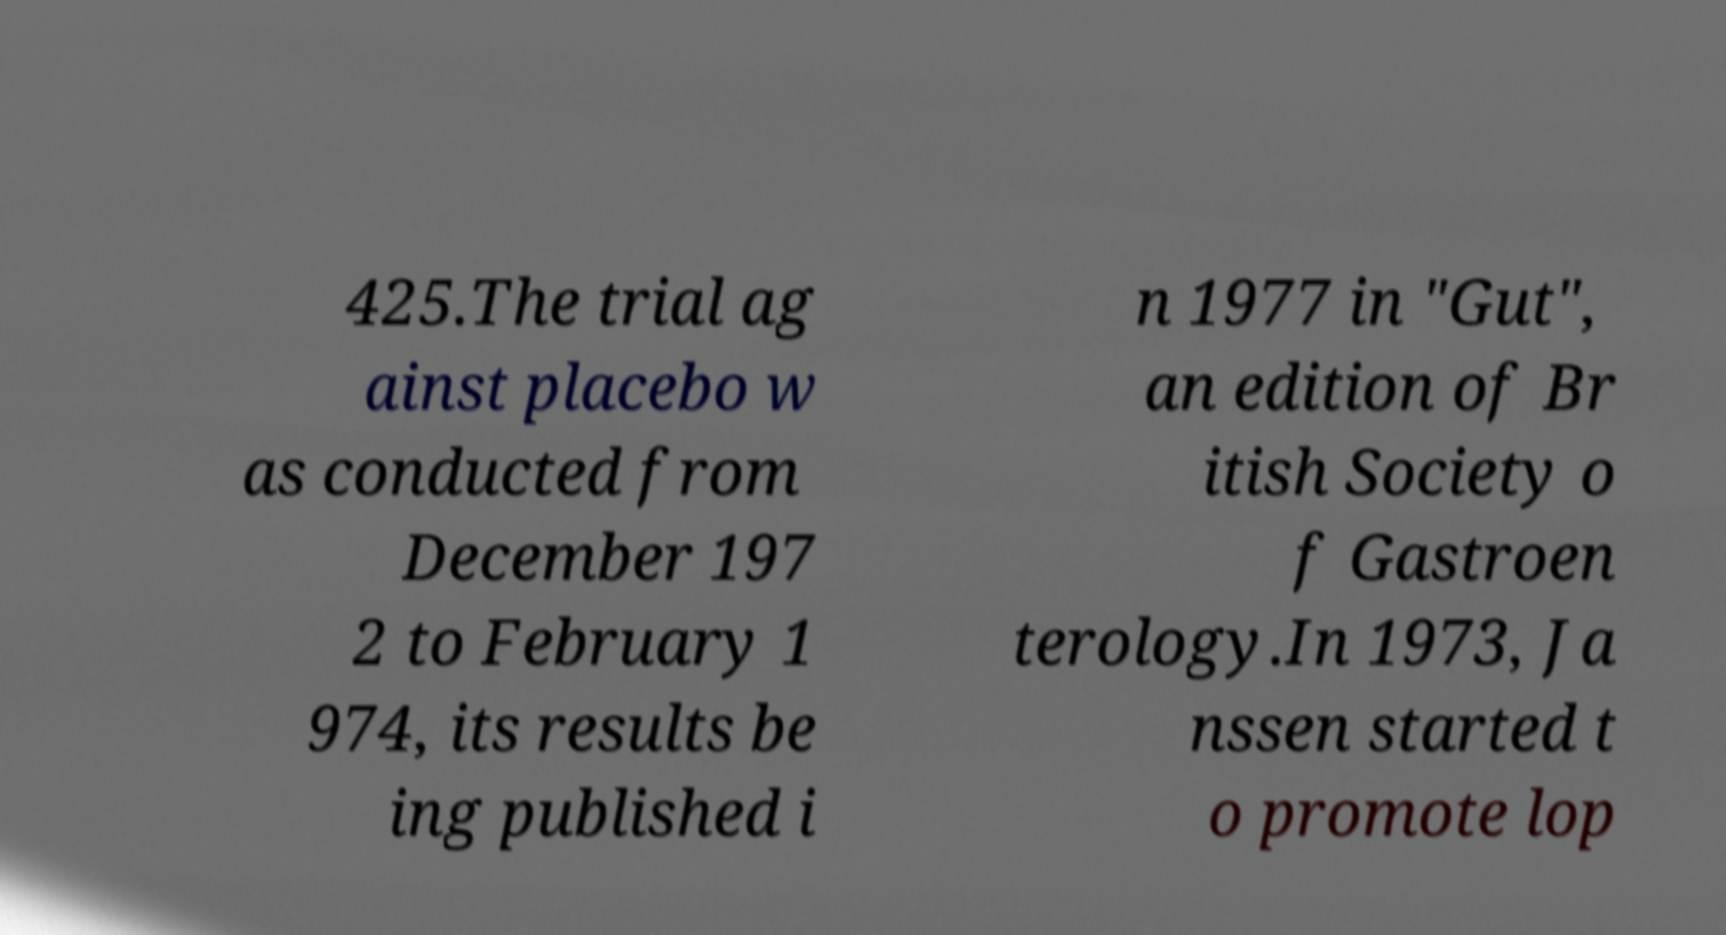Could you extract and type out the text from this image? 425.The trial ag ainst placebo w as conducted from December 197 2 to February 1 974, its results be ing published i n 1977 in "Gut", an edition of Br itish Society o f Gastroen terology.In 1973, Ja nssen started t o promote lop 